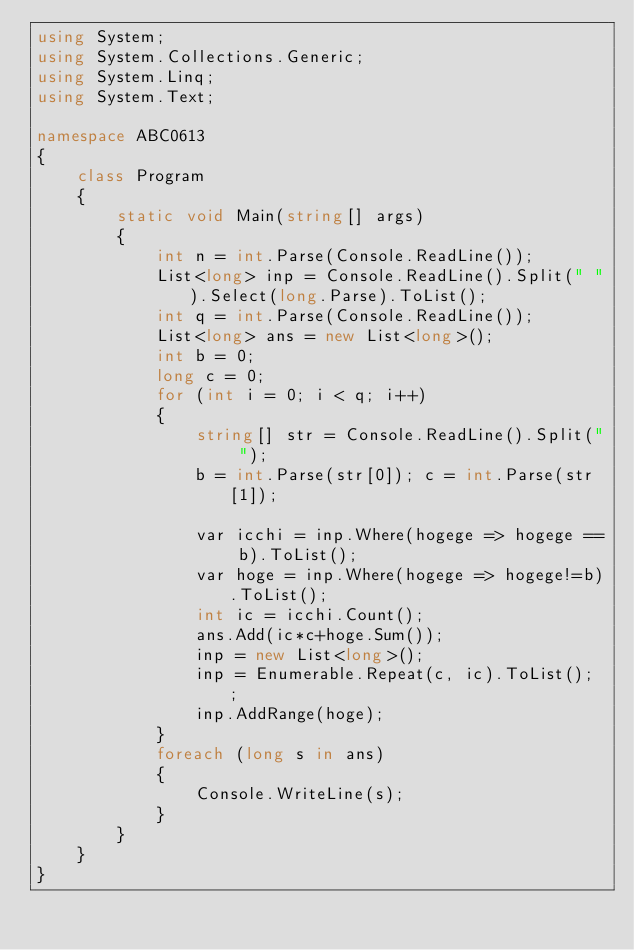<code> <loc_0><loc_0><loc_500><loc_500><_C#_>using System;
using System.Collections.Generic;
using System.Linq;
using System.Text;

namespace ABC0613
{
    class Program
    {
        static void Main(string[] args)
        {
            int n = int.Parse(Console.ReadLine());
            List<long> inp = Console.ReadLine().Split(" ").Select(long.Parse).ToList();
            int q = int.Parse(Console.ReadLine());
            List<long> ans = new List<long>();
            int b = 0;
            long c = 0;
            for (int i = 0; i < q; i++)
            {
                string[] str = Console.ReadLine().Split(" ");
                b = int.Parse(str[0]); c = int.Parse(str[1]);

                var icchi = inp.Where(hogege => hogege == b).ToList();
                var hoge = inp.Where(hogege => hogege!=b).ToList();
                int ic = icchi.Count();
                ans.Add(ic*c+hoge.Sum());
                inp = new List<long>();
                inp = Enumerable.Repeat(c, ic).ToList(); ;
                inp.AddRange(hoge);
            }
            foreach (long s in ans)
            {
                Console.WriteLine(s);
            }
        }
    }
}
</code> 